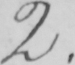Please transcribe the handwritten text in this image. 2 . 